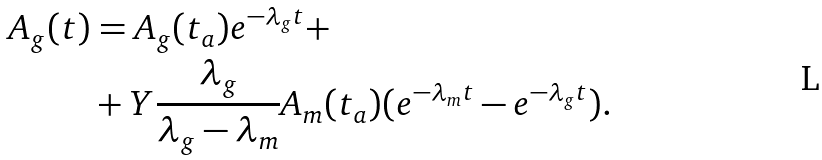<formula> <loc_0><loc_0><loc_500><loc_500>A _ { g } ( t ) & = A _ { g } ( t _ { a } ) e ^ { - \lambda _ { g } t } + \\ & + Y \frac { \lambda _ { g } } { \lambda _ { g } - \lambda _ { m } } A _ { m } ( t _ { a } ) ( e ^ { - \lambda _ { m } t } - e ^ { - \lambda _ { g } t } ) .</formula> 